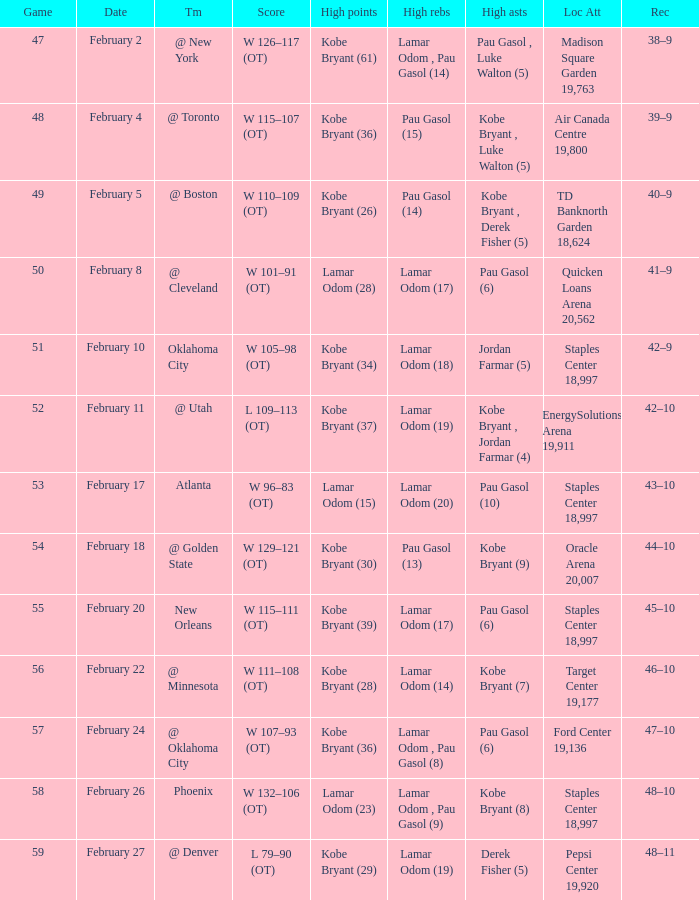Who had the most assists in the game against Atlanta? Pau Gasol (10). 